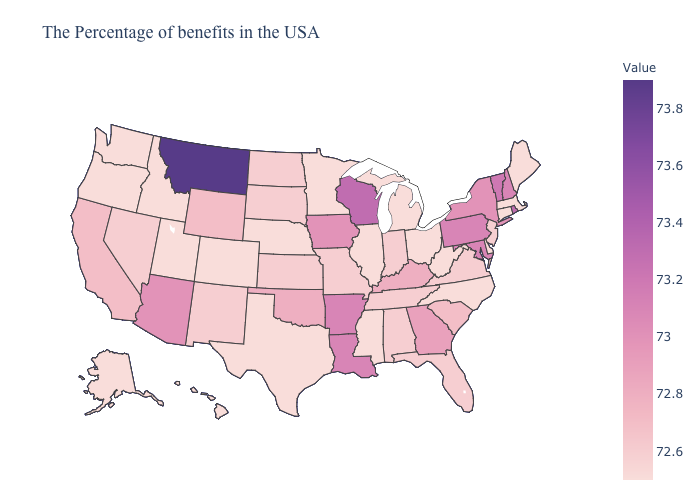Does Virginia have the highest value in the USA?
Quick response, please. No. Does Washington have the lowest value in the USA?
Concise answer only. Yes. Does Massachusetts have the lowest value in the Northeast?
Give a very brief answer. Yes. Which states have the lowest value in the West?
Concise answer only. Colorado, Utah, Idaho, Washington, Oregon, Alaska, Hawaii. Does Georgia have a higher value than Nebraska?
Short answer required. Yes. Among the states that border North Dakota , does South Dakota have the highest value?
Be succinct. No. Among the states that border Iowa , which have the lowest value?
Keep it brief. Illinois, Minnesota, Nebraska. 